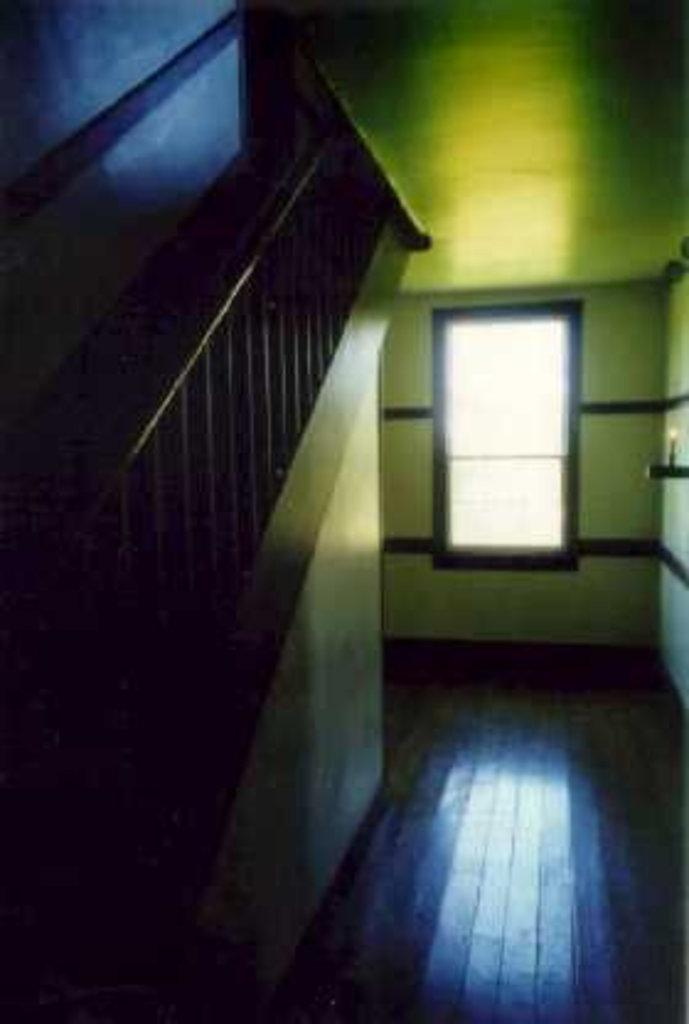What structure is located on the left side of the image? There is a wall on the left side of the image. What architectural feature can be seen in the image? There is a staircase in the image. What can be seen in the background of the image? There is a window visible in the background of the image. What type of flesh can be seen hanging from the wall in the image? There is no flesh present in the image; it features a wall, a staircase, and a window. Can you tell me how many ducks are sitting on the throne in the image? There is no throne or ducks present in the image. 